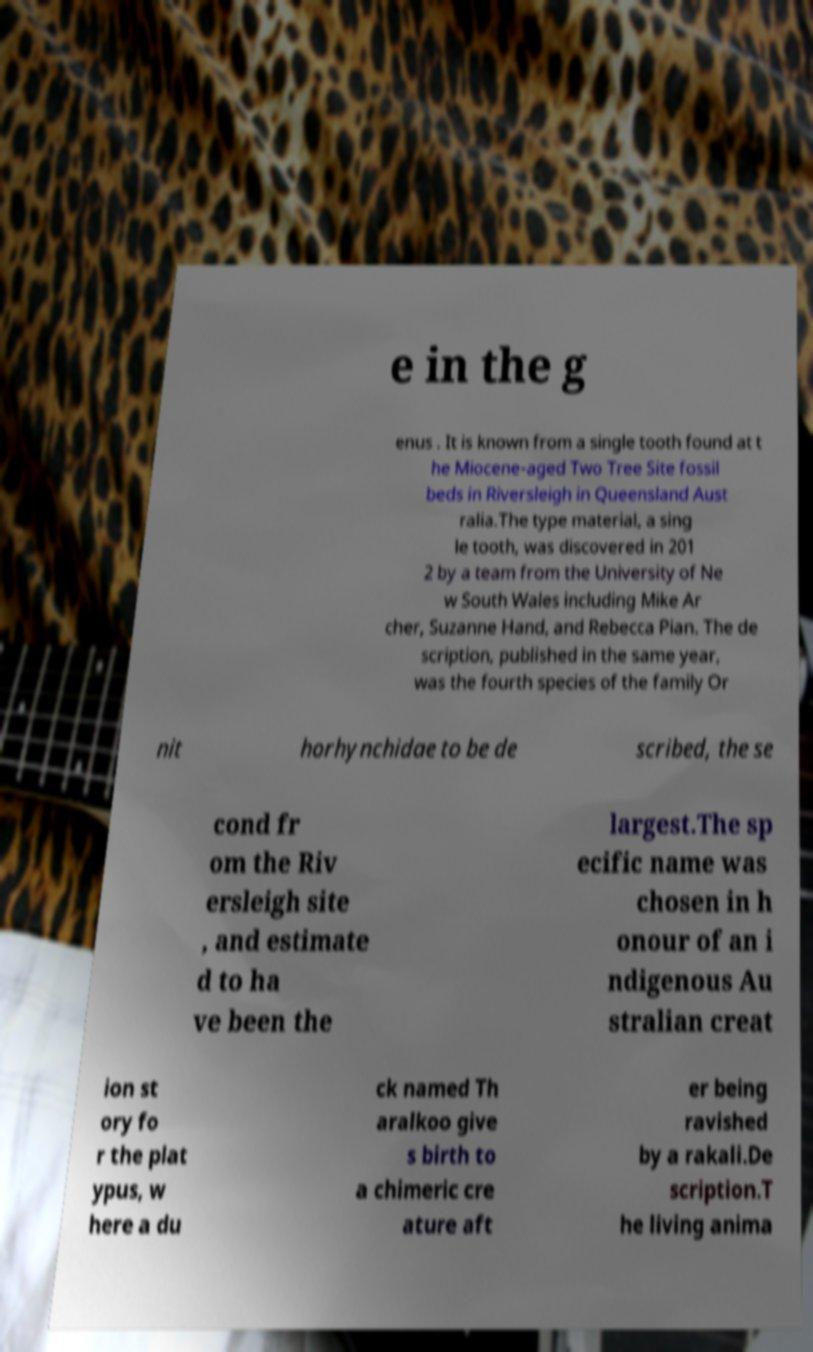Could you extract and type out the text from this image? e in the g enus . It is known from a single tooth found at t he Miocene-aged Two Tree Site fossil beds in Riversleigh in Queensland Aust ralia.The type material, a sing le tooth, was discovered in 201 2 by a team from the University of Ne w South Wales including Mike Ar cher, Suzanne Hand, and Rebecca Pian. The de scription, published in the same year, was the fourth species of the family Or nit horhynchidae to be de scribed, the se cond fr om the Riv ersleigh site , and estimate d to ha ve been the largest.The sp ecific name was chosen in h onour of an i ndigenous Au stralian creat ion st ory fo r the plat ypus, w here a du ck named Th aralkoo give s birth to a chimeric cre ature aft er being ravished by a rakali.De scription.T he living anima 